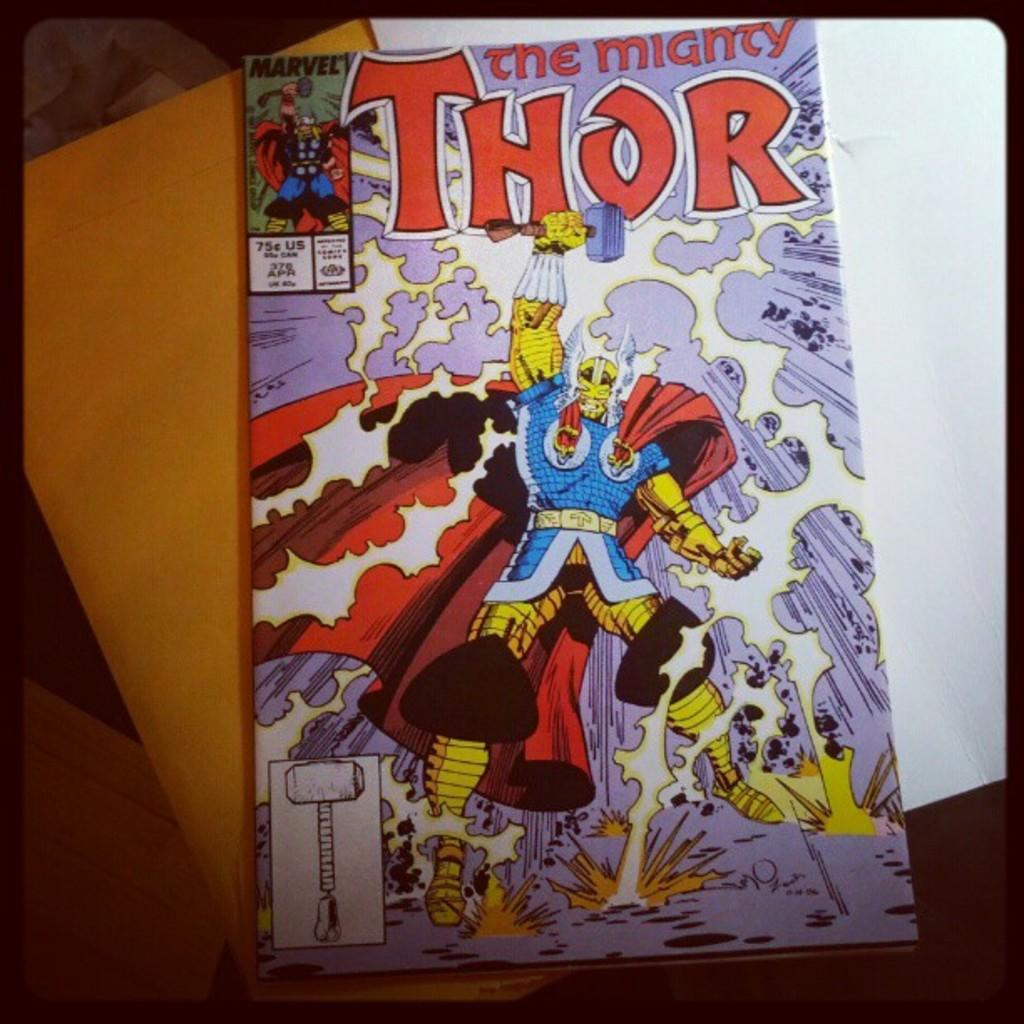<image>
Create a compact narrative representing the image presented. A comic titled Thor has a guy in a red cape on it. 